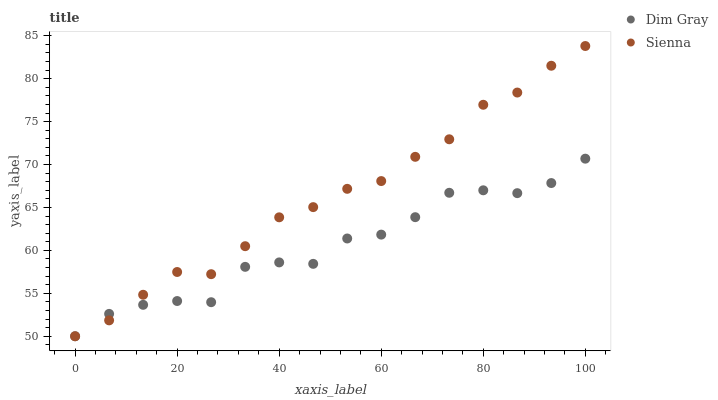Does Dim Gray have the minimum area under the curve?
Answer yes or no. Yes. Does Sienna have the maximum area under the curve?
Answer yes or no. Yes. Does Dim Gray have the maximum area under the curve?
Answer yes or no. No. Is Sienna the smoothest?
Answer yes or no. Yes. Is Dim Gray the roughest?
Answer yes or no. Yes. Is Dim Gray the smoothest?
Answer yes or no. No. Does Sienna have the lowest value?
Answer yes or no. Yes. Does Sienna have the highest value?
Answer yes or no. Yes. Does Dim Gray have the highest value?
Answer yes or no. No. Does Sienna intersect Dim Gray?
Answer yes or no. Yes. Is Sienna less than Dim Gray?
Answer yes or no. No. Is Sienna greater than Dim Gray?
Answer yes or no. No. 